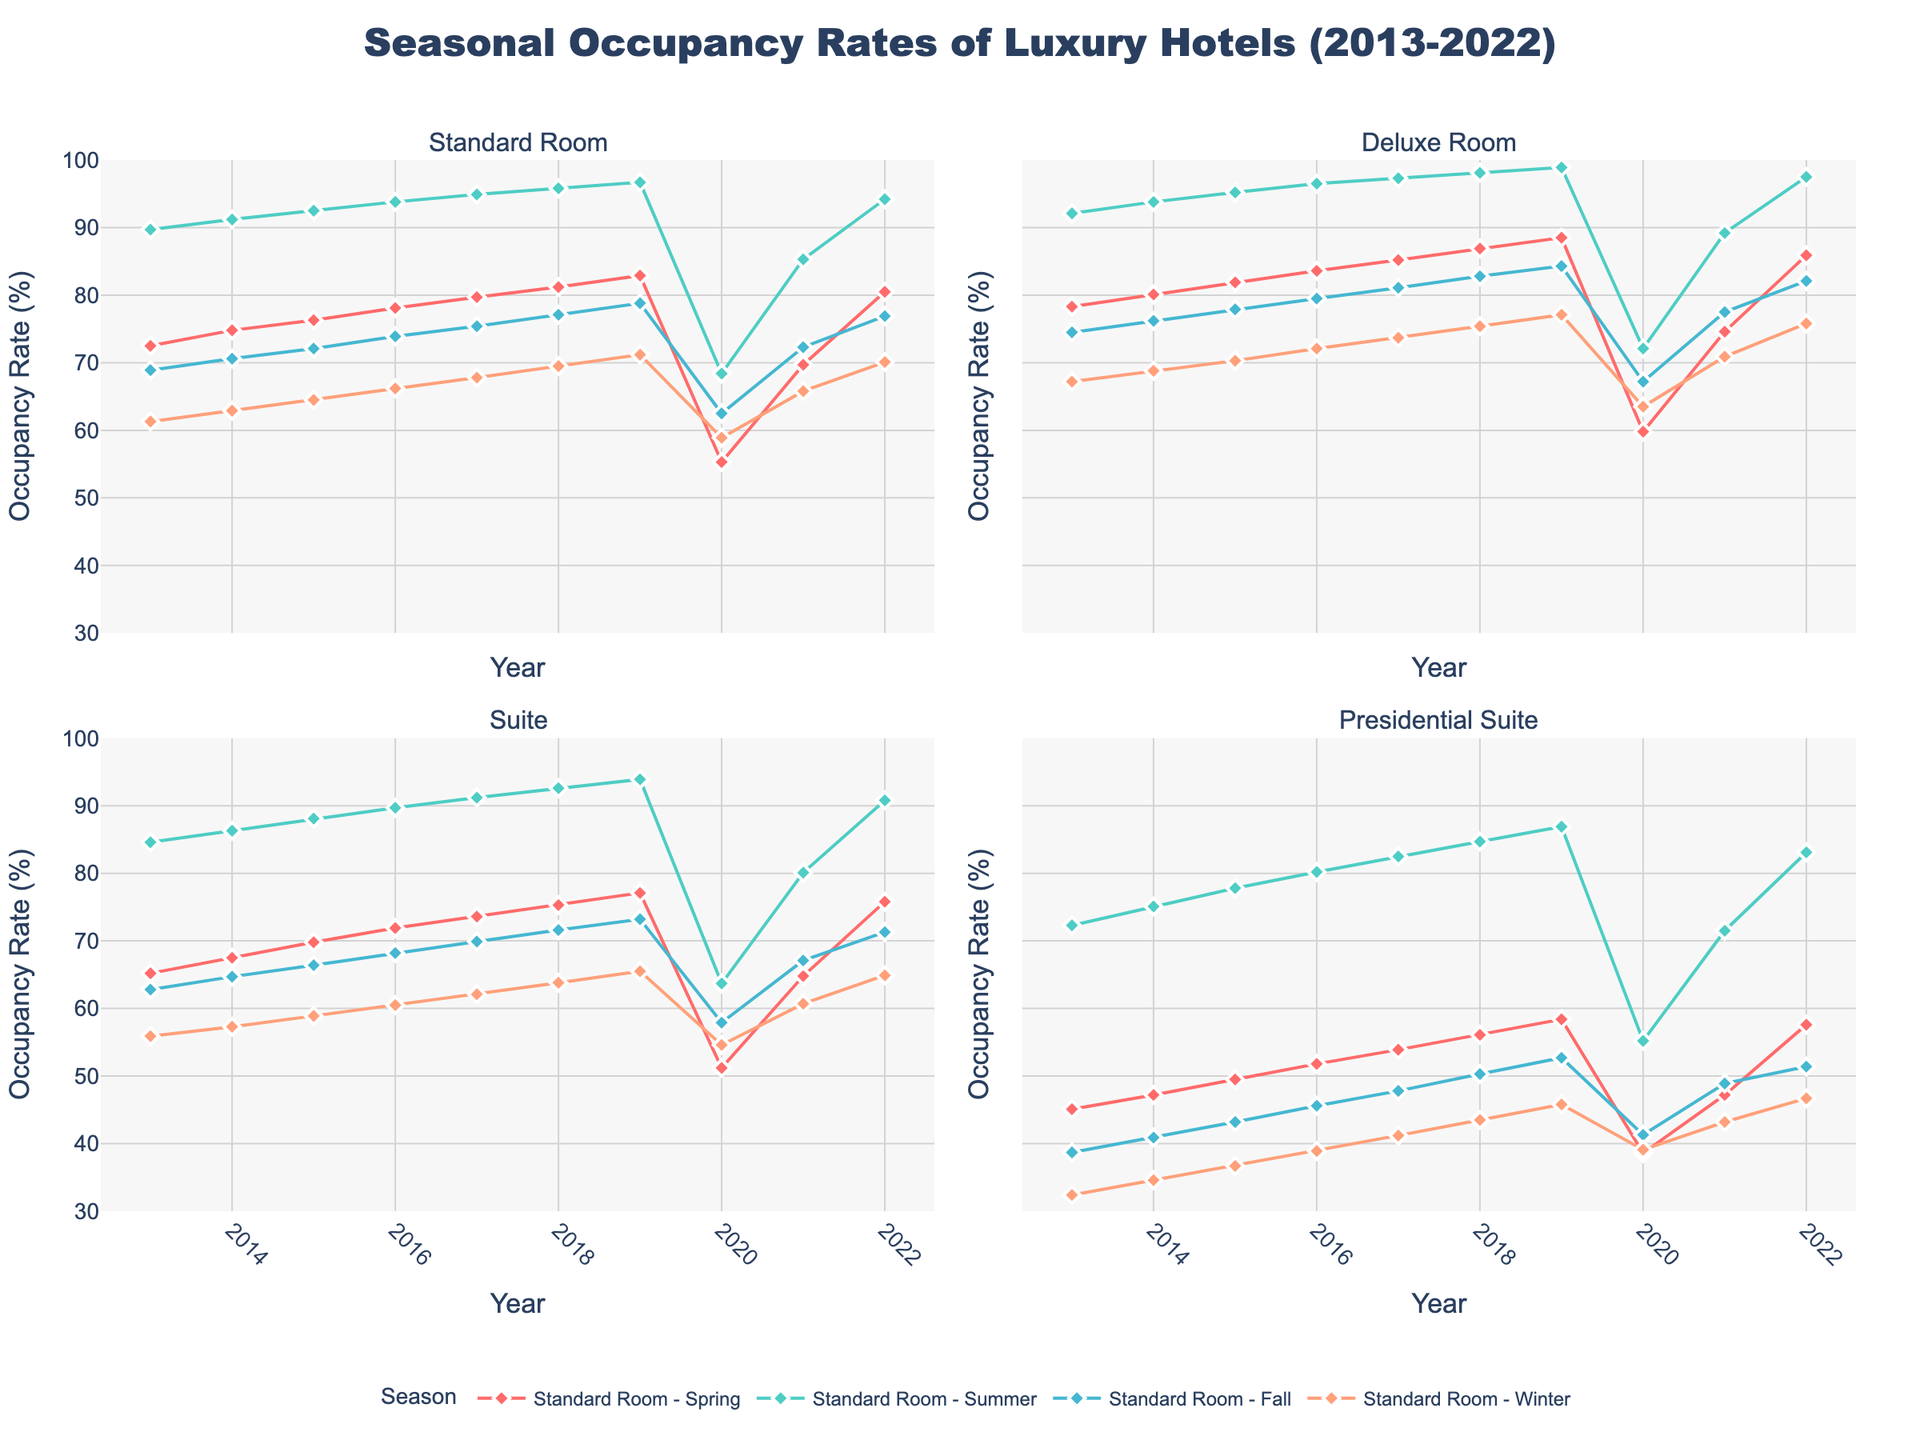Which room type had the highest occupancy rate during the summer of 2019? To find the highest occupancy rate, look at the summer of 2019 across all four room types. The Presidential Suite has the highest rate at 86.9%.
Answer: Presidential Suite Which season generally shows the lowest occupancy rates across the years for Standard Rooms? Look at the lines representing Standard Rooms for each season. Winter seems to consistently show lower rates than the other seasons.
Answer: Winter What's the average winter occupancy rate for Deluxe Rooms from 2013 to 2022? Calculate the average by summing the winter occupancy rates for each year and dividing by the number of years (67.2+68.8+70.3+72.1+73.7+75.4+77.1+63.5+70.9+75.8)/10 = 71.48%.
Answer: 71.48% Compare the occupancy trend of Spring for Suites from 2013 to 2022. Is it generally increasing or decreasing? Examine the trend line for Spring in the Suite subplot. The general occupancy trend appears to be increasing over the decade.
Answer: Increasing Which year had the largest drop in occupancy rate for Presidential Suites between two consecutive seasons? Look at the lines for Presidential Suites to find the steepest drop. The largest drop occurs between Summer and Fall in 2020, decreasing from 55.2% to 41.3%.
Answer: 2020 During which year do all room types peak during the Summer season? Check each room-type subplot to see if there's a common peak in Summer across all types. All room types peak in Summer in several years including 2019.
Answer: 2019 By how much did the Spring occupancy rates for Standard Rooms increase from 2020 to 2021? Subtract the 2020 Spring rate from the 2021 Spring rate (69.7% - 55.3% = 14.4%).
Answer: 14.4% For the Deluxe Room, which season in 2022 had the highest occupancy rate? Find the highest occupancy rate for Deluxe Rooms in 2022. Summer had the highest at 97.5%.
Answer: Summer Over the decade, which room type appears to have the most consistent seasonal occupancy rates? Compare the variability of all room types across seasons and years. The Presidential Suite shows a more consistent trend without large fluctuations.
Answer: Presidential Suite Whether occupancy rates for Standard Rooms in Fall tend to be higher or lower compared to Spring? Compare the lines for Spring and Fall in the Standard Room subplot. Fall tends to have slightly lower occupancy than Spring most years.
Answer: Lower 